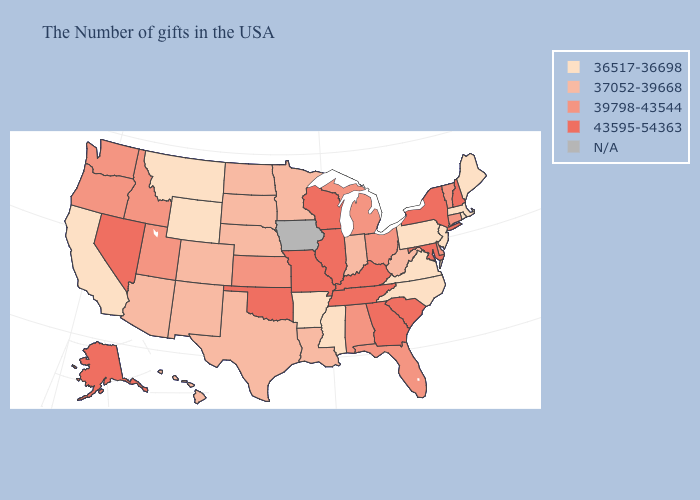Which states have the lowest value in the West?
Be succinct. Wyoming, Montana, California. Among the states that border Massachusetts , which have the lowest value?
Answer briefly. Rhode Island. What is the value of South Carolina?
Quick response, please. 43595-54363. Does Arkansas have the highest value in the USA?
Keep it brief. No. Is the legend a continuous bar?
Quick response, please. No. Is the legend a continuous bar?
Keep it brief. No. What is the value of Kansas?
Be succinct. 39798-43544. Does Virginia have the lowest value in the USA?
Short answer required. Yes. Which states hav the highest value in the West?
Give a very brief answer. Nevada, Alaska. Does Minnesota have the lowest value in the MidWest?
Answer briefly. Yes. What is the value of Wisconsin?
Write a very short answer. 43595-54363. 